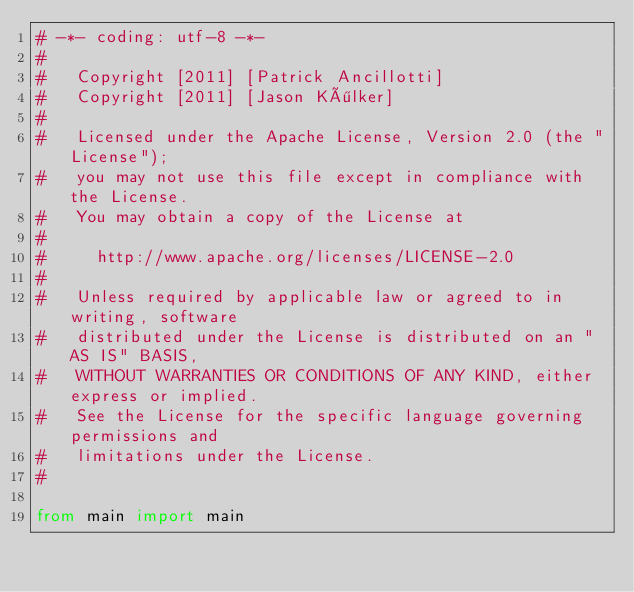Convert code to text. <code><loc_0><loc_0><loc_500><loc_500><_Python_># -*- coding: utf-8 -*-
#
#   Copyright [2011] [Patrick Ancillotti]
#   Copyright [2011] [Jason Kölker]
#
#   Licensed under the Apache License, Version 2.0 (the "License");
#   you may not use this file except in compliance with the License.
#   You may obtain a copy of the License at
#
#     http://www.apache.org/licenses/LICENSE-2.0
#
#   Unless required by applicable law or agreed to in writing, software
#   distributed under the License is distributed on an "AS IS" BASIS,
#   WITHOUT WARRANTIES OR CONDITIONS OF ANY KIND, either express or implied.
#   See the License for the specific language governing permissions and
#   limitations under the License.
#

from main import main
</code> 